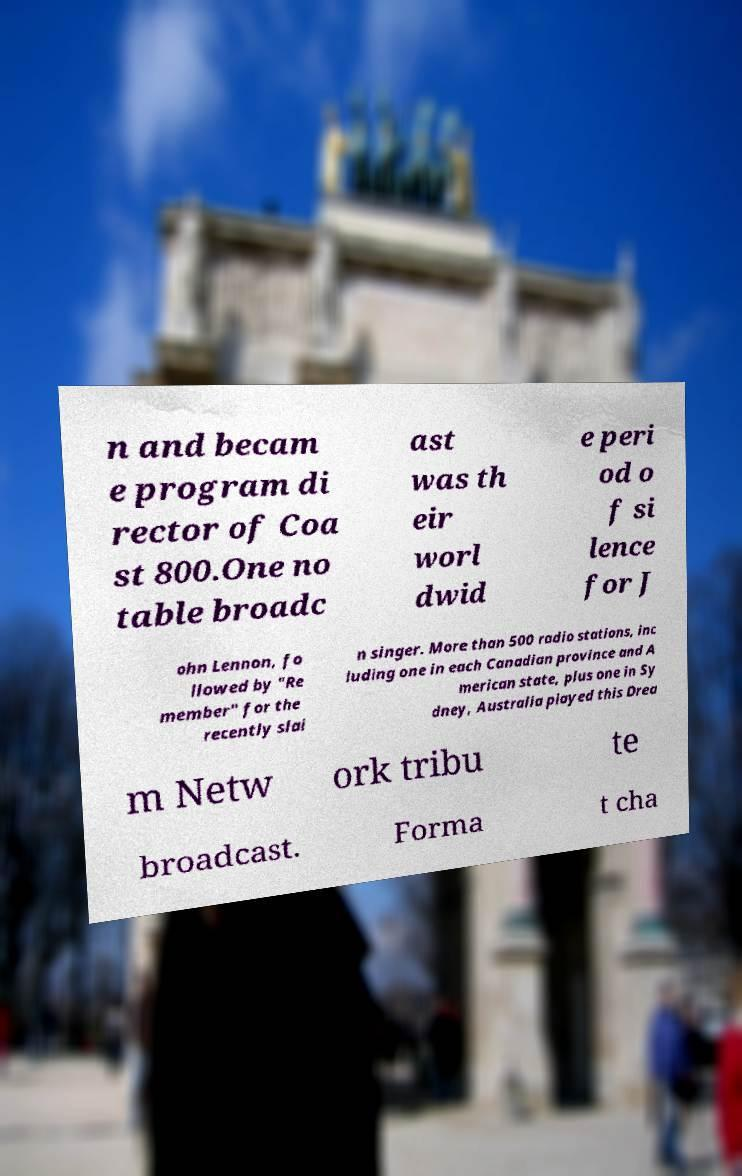I need the written content from this picture converted into text. Can you do that? n and becam e program di rector of Coa st 800.One no table broadc ast was th eir worl dwid e peri od o f si lence for J ohn Lennon, fo llowed by "Re member" for the recently slai n singer. More than 500 radio stations, inc luding one in each Canadian province and A merican state, plus one in Sy dney, Australia played this Drea m Netw ork tribu te broadcast. Forma t cha 